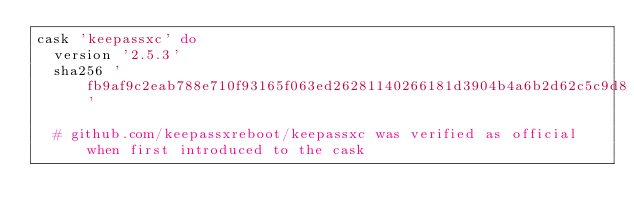<code> <loc_0><loc_0><loc_500><loc_500><_Ruby_>cask 'keepassxc' do
  version '2.5.3'
  sha256 'fb9af9c2eab788e710f93165f063ed26281140266181d3904b4a6b2d62c5c9d8'

  # github.com/keepassxreboot/keepassxc was verified as official when first introduced to the cask</code> 